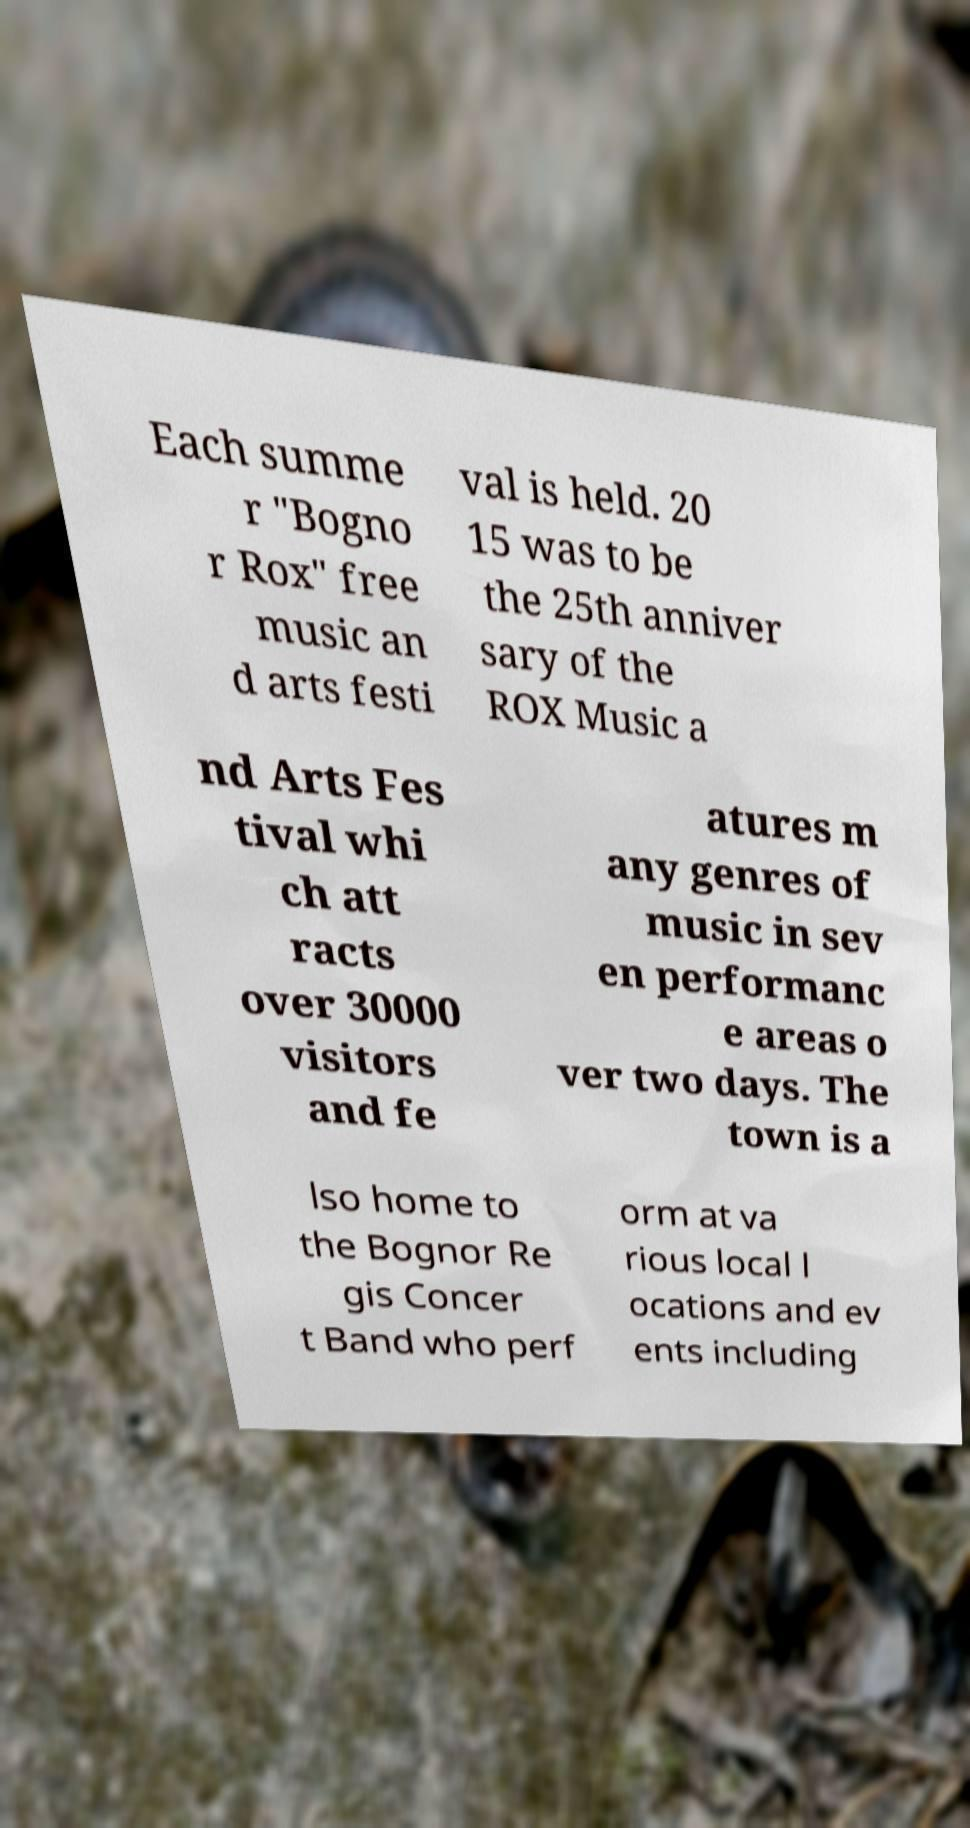What messages or text are displayed in this image? I need them in a readable, typed format. Each summe r "Bogno r Rox" free music an d arts festi val is held. 20 15 was to be the 25th anniver sary of the ROX Music a nd Arts Fes tival whi ch att racts over 30000 visitors and fe atures m any genres of music in sev en performanc e areas o ver two days. The town is a lso home to the Bognor Re gis Concer t Band who perf orm at va rious local l ocations and ev ents including 